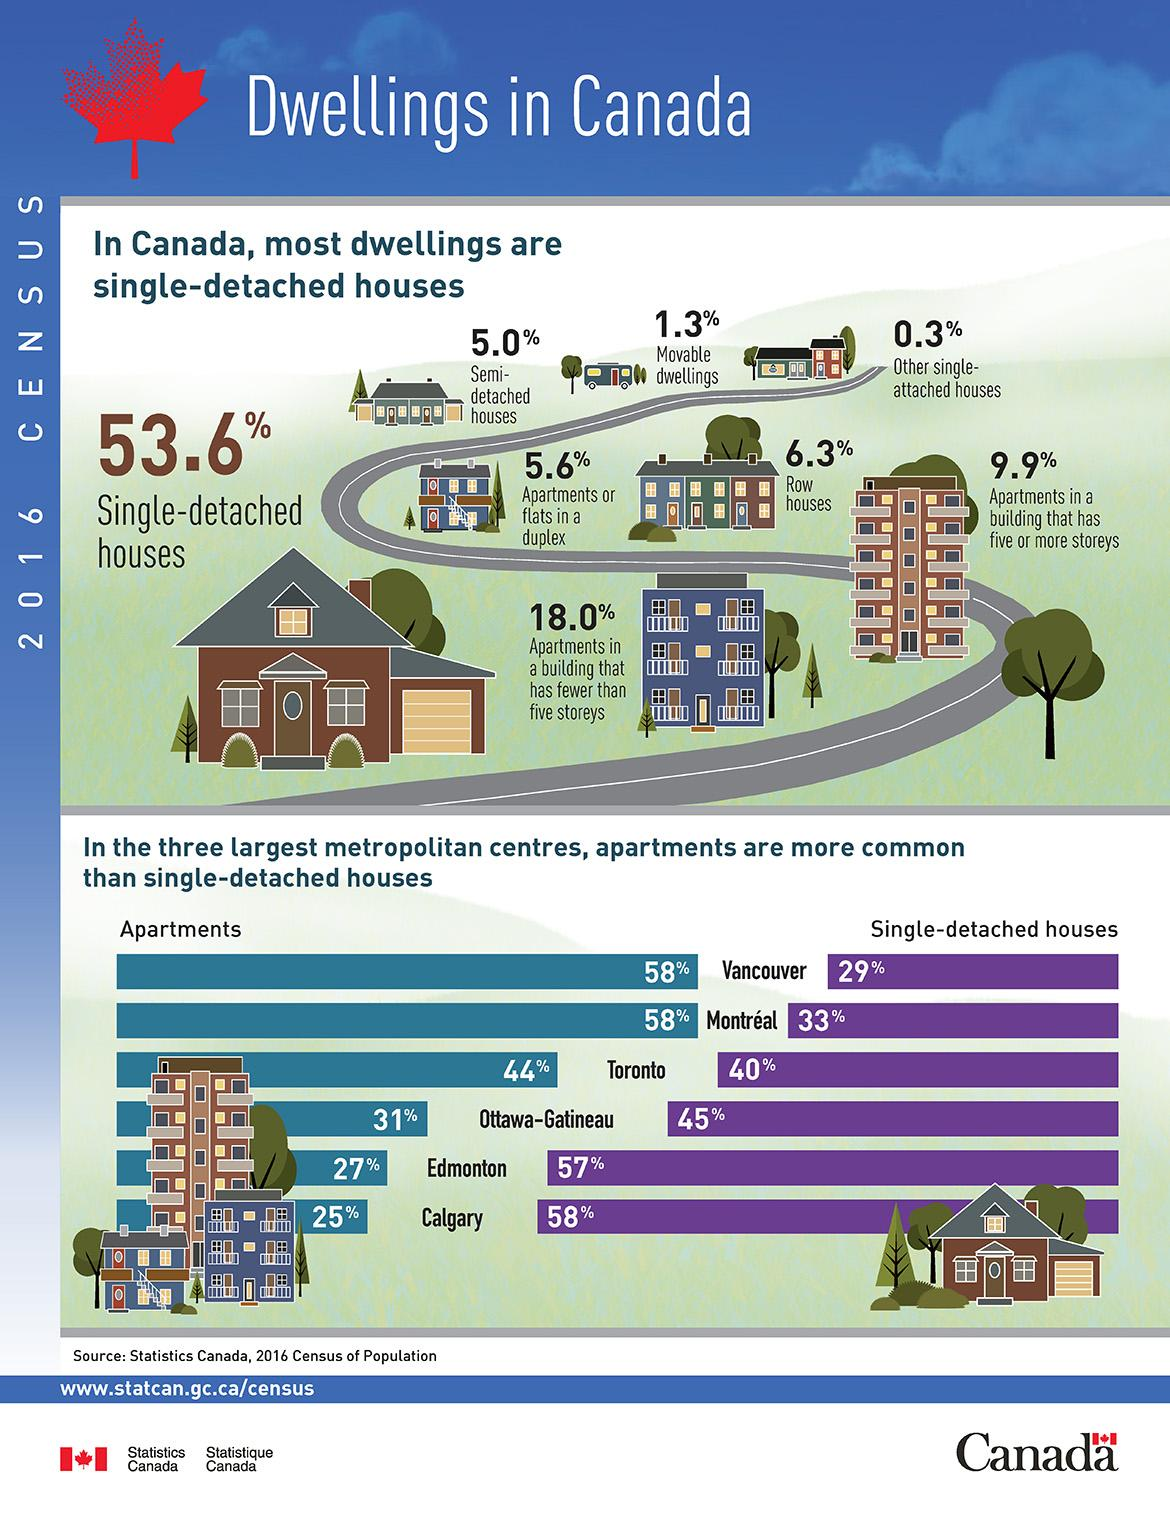Draw attention to some important aspects in this diagram. According to recent statistics, approximately 84% of the housing stock in Toronto consists of apartments and single-detached houses. According to the data provided, the percentage of Semi-detached houses is 5.0%. The combined percentage of apartments in Toronto and Edmonton is 71%. In Calgary, 83% of the total housing inventory consists of both apartments and single-detached houses. Approximately 5.6% of duplexes consist of apartments or flats. 